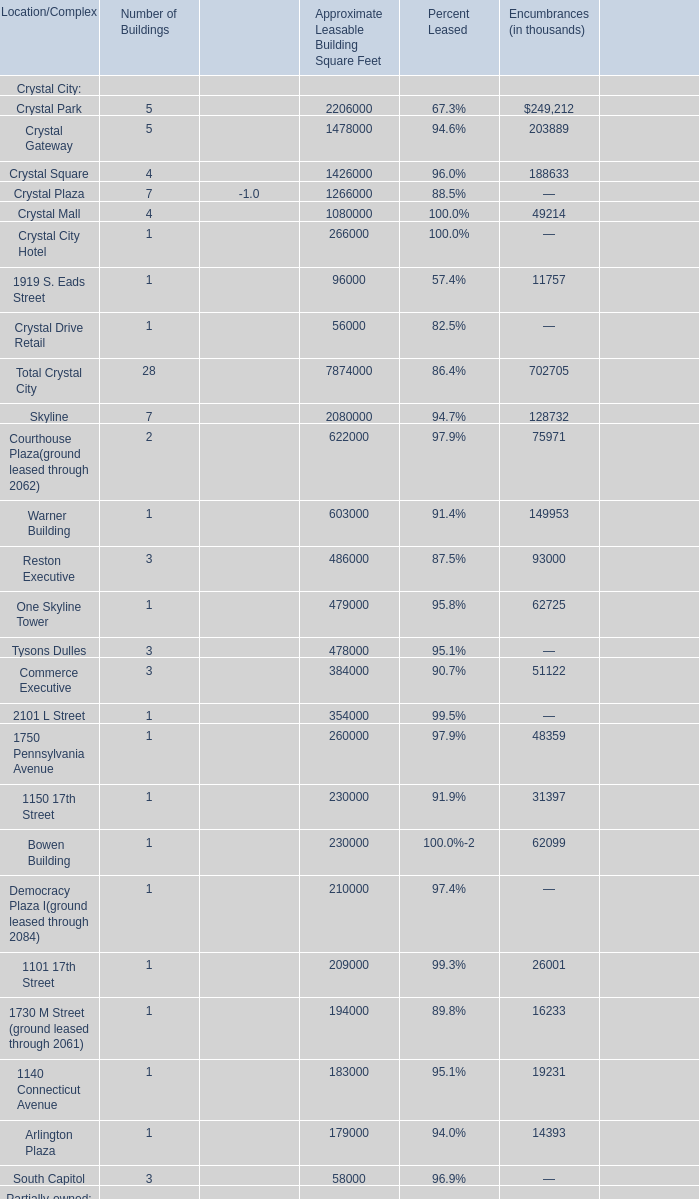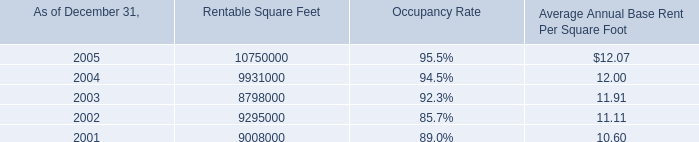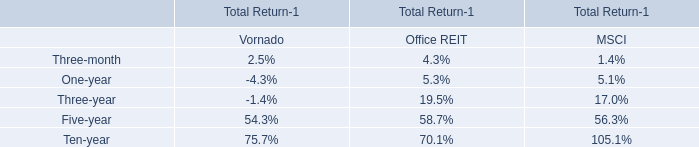What's the Total Number of Buildings in Crystal City? 
Answer: 28. 